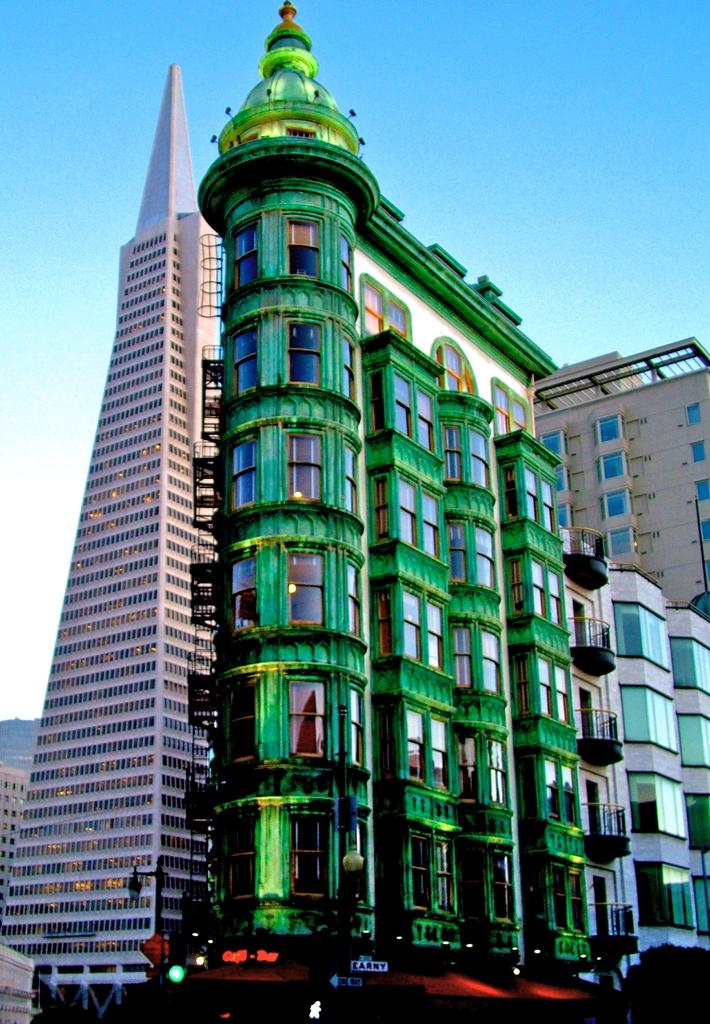What structures are present in the image? There are buildings in the image. What part of the natural environment is visible in the image? The sky is visible in the background of the image. What direction is the baseball being thrown in the image? There is no baseball present in the image. What type of pull-up exercise is being performed in the image? There is no exercise or physical activity depicted in the image. 